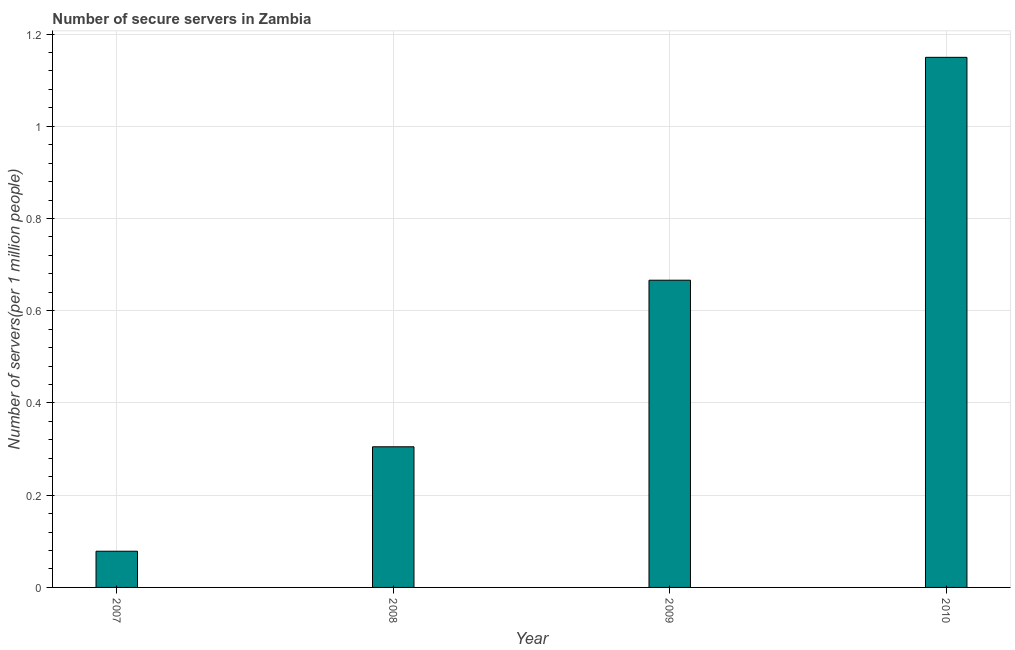Does the graph contain grids?
Your answer should be compact. Yes. What is the title of the graph?
Ensure brevity in your answer.  Number of secure servers in Zambia. What is the label or title of the X-axis?
Provide a succinct answer. Year. What is the label or title of the Y-axis?
Offer a very short reply. Number of servers(per 1 million people). What is the number of secure internet servers in 2008?
Your answer should be very brief. 0.31. Across all years, what is the maximum number of secure internet servers?
Your response must be concise. 1.15. Across all years, what is the minimum number of secure internet servers?
Provide a short and direct response. 0.08. In which year was the number of secure internet servers minimum?
Your response must be concise. 2007. What is the sum of the number of secure internet servers?
Make the answer very short. 2.2. What is the difference between the number of secure internet servers in 2009 and 2010?
Your response must be concise. -0.48. What is the average number of secure internet servers per year?
Ensure brevity in your answer.  0.55. What is the median number of secure internet servers?
Offer a very short reply. 0.49. In how many years, is the number of secure internet servers greater than 0.48 ?
Your answer should be compact. 2. What is the ratio of the number of secure internet servers in 2008 to that in 2009?
Give a very brief answer. 0.46. Is the number of secure internet servers in 2007 less than that in 2008?
Make the answer very short. Yes. What is the difference between the highest and the second highest number of secure internet servers?
Keep it short and to the point. 0.48. What is the difference between the highest and the lowest number of secure internet servers?
Your answer should be very brief. 1.07. In how many years, is the number of secure internet servers greater than the average number of secure internet servers taken over all years?
Keep it short and to the point. 2. How many bars are there?
Your answer should be very brief. 4. Are all the bars in the graph horizontal?
Offer a very short reply. No. How many years are there in the graph?
Provide a short and direct response. 4. Are the values on the major ticks of Y-axis written in scientific E-notation?
Provide a short and direct response. No. What is the Number of servers(per 1 million people) of 2007?
Give a very brief answer. 0.08. What is the Number of servers(per 1 million people) in 2008?
Offer a terse response. 0.31. What is the Number of servers(per 1 million people) of 2009?
Offer a very short reply. 0.67. What is the Number of servers(per 1 million people) of 2010?
Your response must be concise. 1.15. What is the difference between the Number of servers(per 1 million people) in 2007 and 2008?
Ensure brevity in your answer.  -0.23. What is the difference between the Number of servers(per 1 million people) in 2007 and 2009?
Give a very brief answer. -0.59. What is the difference between the Number of servers(per 1 million people) in 2007 and 2010?
Give a very brief answer. -1.07. What is the difference between the Number of servers(per 1 million people) in 2008 and 2009?
Offer a very short reply. -0.36. What is the difference between the Number of servers(per 1 million people) in 2008 and 2010?
Your response must be concise. -0.84. What is the difference between the Number of servers(per 1 million people) in 2009 and 2010?
Your answer should be compact. -0.48. What is the ratio of the Number of servers(per 1 million people) in 2007 to that in 2008?
Give a very brief answer. 0.26. What is the ratio of the Number of servers(per 1 million people) in 2007 to that in 2009?
Ensure brevity in your answer.  0.12. What is the ratio of the Number of servers(per 1 million people) in 2007 to that in 2010?
Offer a terse response. 0.07. What is the ratio of the Number of servers(per 1 million people) in 2008 to that in 2009?
Provide a succinct answer. 0.46. What is the ratio of the Number of servers(per 1 million people) in 2008 to that in 2010?
Ensure brevity in your answer.  0.27. What is the ratio of the Number of servers(per 1 million people) in 2009 to that in 2010?
Offer a very short reply. 0.58. 